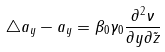<formula> <loc_0><loc_0><loc_500><loc_500>\triangle a _ { y } - a _ { y } = \beta _ { 0 } \gamma _ { 0 } \frac { \partial ^ { 2 } \nu } { \partial y \partial \tilde { z } }</formula> 